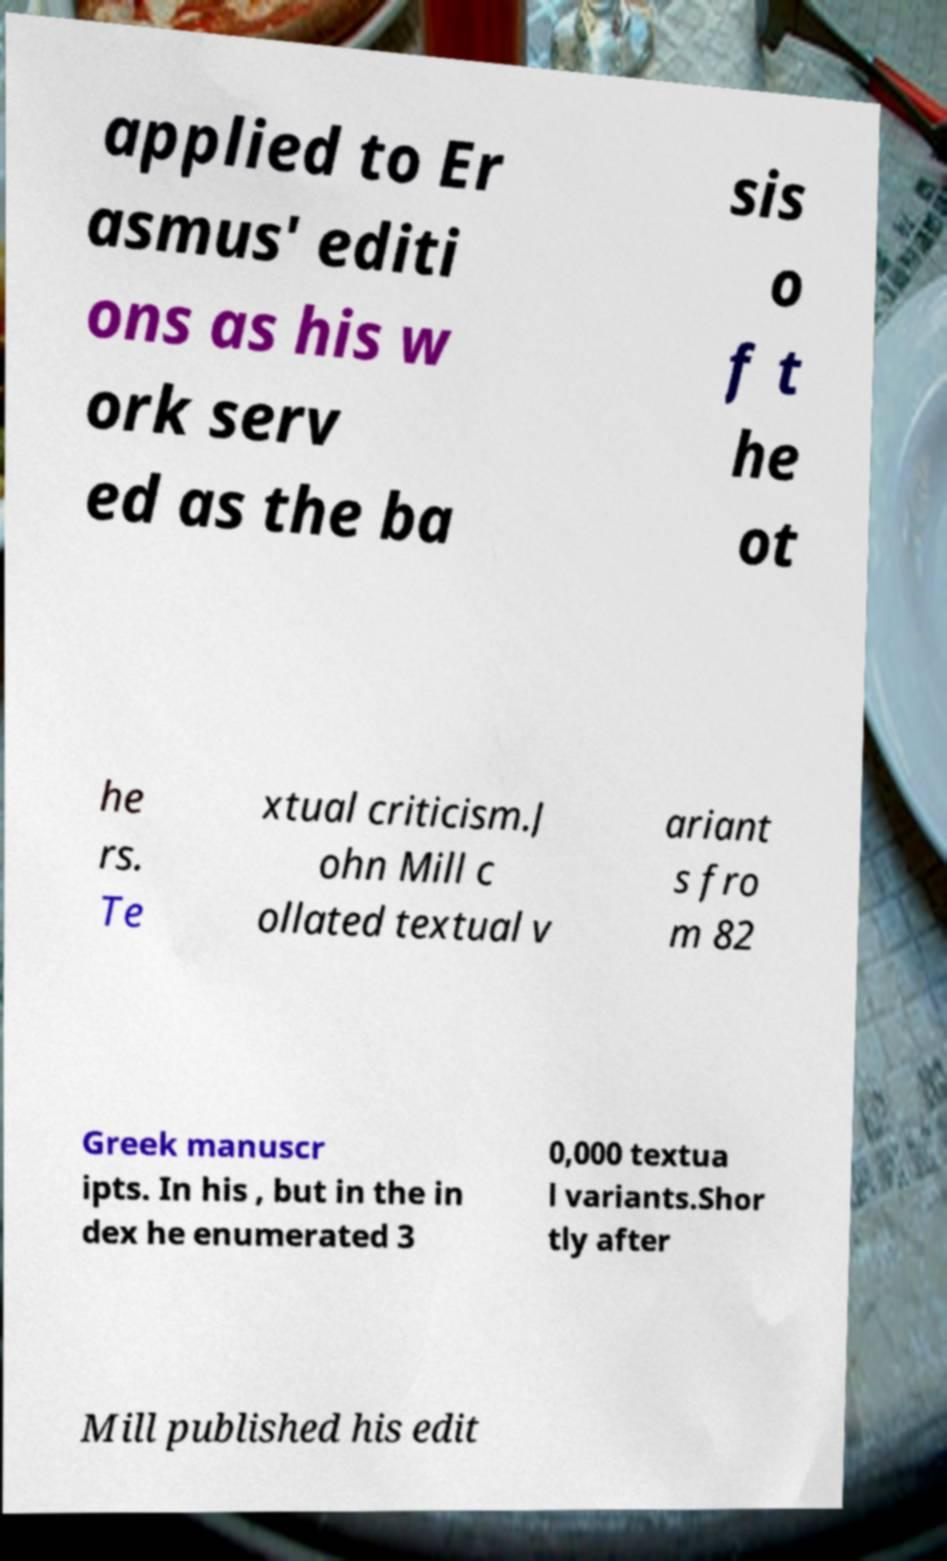Can you read and provide the text displayed in the image?This photo seems to have some interesting text. Can you extract and type it out for me? applied to Er asmus' editi ons as his w ork serv ed as the ba sis o f t he ot he rs. Te xtual criticism.J ohn Mill c ollated textual v ariant s fro m 82 Greek manuscr ipts. In his , but in the in dex he enumerated 3 0,000 textua l variants.Shor tly after Mill published his edit 